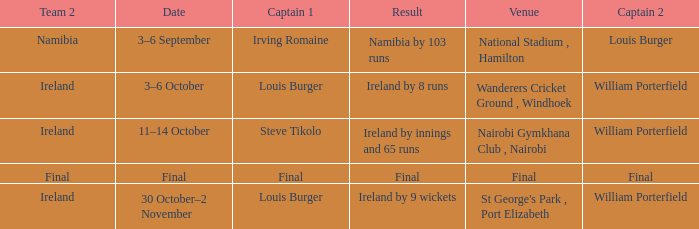Which Captain 2 has a Result of final? Final. 